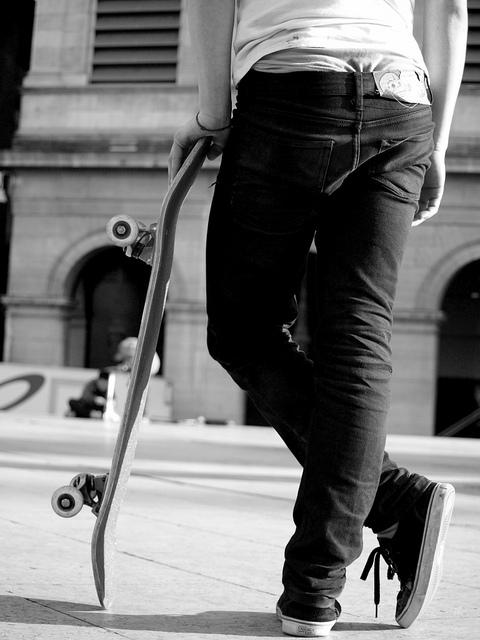Is this a rural area?
Give a very brief answer. No. What is the person leaning on?
Short answer required. Skateboard. Is the person wearing a bracelet?
Write a very short answer. Yes. 